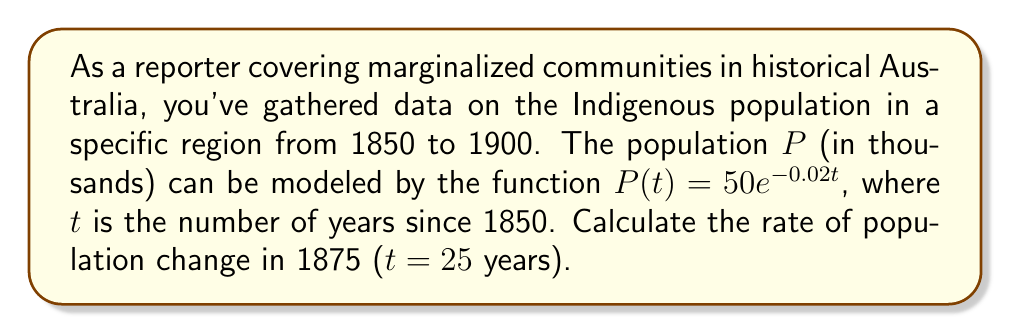What is the answer to this math problem? To solve this problem, we need to find the derivative of the population function P(t) and then evaluate it at t = 25. This will give us the instantaneous rate of change of the population in 1875.

Step 1: Find the derivative of P(t)
The function is given as $P(t) = 50e^{-0.02t}$
Using the chain rule, we get:
$$\frac{dP}{dt} = 50 \cdot (-0.02) \cdot e^{-0.02t}$$
$$\frac{dP}{dt} = -e^{-0.02t}$$

Step 2: Evaluate the derivative at t = 25
$$\frac{dP}{dt}|_{t=25} = -e^{-0.02(25)}$$
$$= -e^{-0.5}$$
$$\approx -0.6065$$

Step 3: Interpret the result
The negative value indicates that the population is decreasing. The rate of change is approximately -0.6065 thousand people per year, or about -607 people per year in 1875.
Answer: The rate of population change in 1875 is approximately -0.6065 thousand people per year, or -607 people per year. 